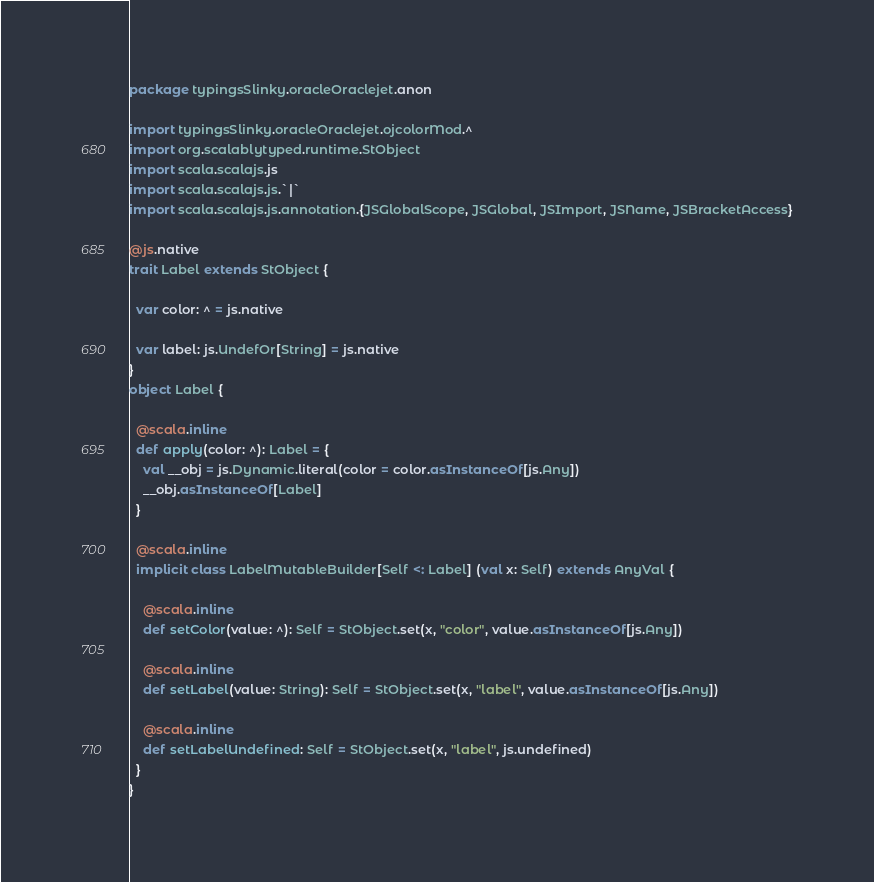<code> <loc_0><loc_0><loc_500><loc_500><_Scala_>package typingsSlinky.oracleOraclejet.anon

import typingsSlinky.oracleOraclejet.ojcolorMod.^
import org.scalablytyped.runtime.StObject
import scala.scalajs.js
import scala.scalajs.js.`|`
import scala.scalajs.js.annotation.{JSGlobalScope, JSGlobal, JSImport, JSName, JSBracketAccess}

@js.native
trait Label extends StObject {
  
  var color: ^ = js.native
  
  var label: js.UndefOr[String] = js.native
}
object Label {
  
  @scala.inline
  def apply(color: ^): Label = {
    val __obj = js.Dynamic.literal(color = color.asInstanceOf[js.Any])
    __obj.asInstanceOf[Label]
  }
  
  @scala.inline
  implicit class LabelMutableBuilder[Self <: Label] (val x: Self) extends AnyVal {
    
    @scala.inline
    def setColor(value: ^): Self = StObject.set(x, "color", value.asInstanceOf[js.Any])
    
    @scala.inline
    def setLabel(value: String): Self = StObject.set(x, "label", value.asInstanceOf[js.Any])
    
    @scala.inline
    def setLabelUndefined: Self = StObject.set(x, "label", js.undefined)
  }
}
</code> 